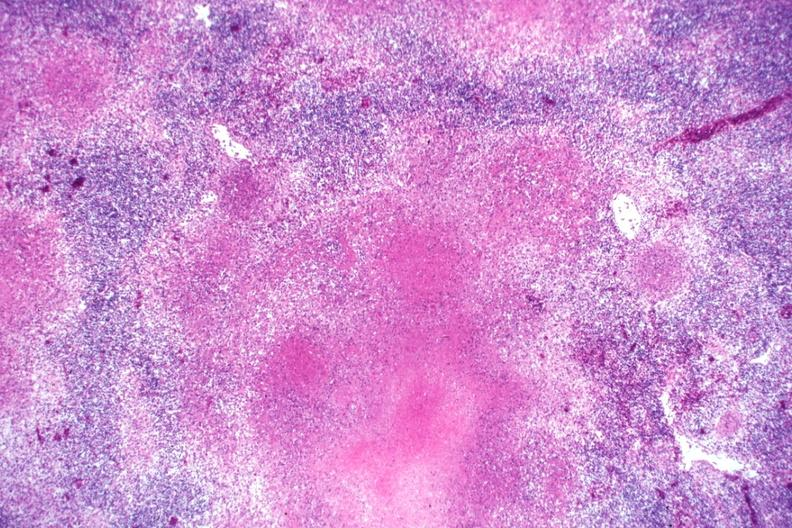does close-up tumor show typical necrotizing granulomata becoming confluent an excellent slide?
Answer the question using a single word or phrase. No 